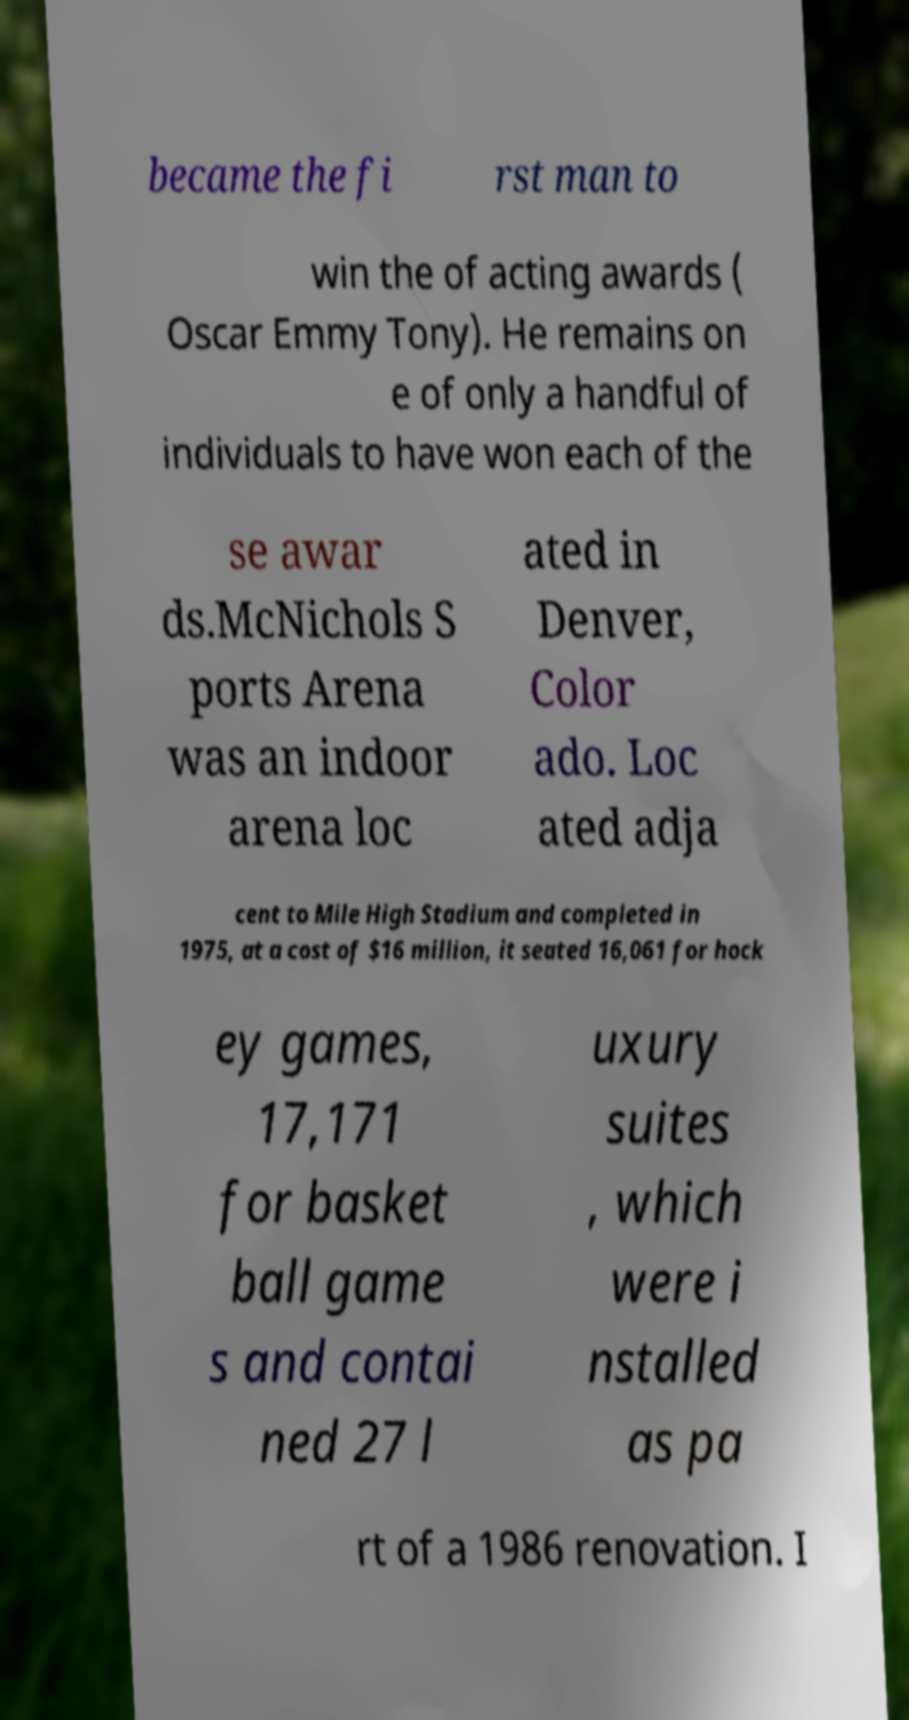Please identify and transcribe the text found in this image. became the fi rst man to win the of acting awards ( Oscar Emmy Tony). He remains on e of only a handful of individuals to have won each of the se awar ds.McNichols S ports Arena was an indoor arena loc ated in Denver, Color ado. Loc ated adja cent to Mile High Stadium and completed in 1975, at a cost of $16 million, it seated 16,061 for hock ey games, 17,171 for basket ball game s and contai ned 27 l uxury suites , which were i nstalled as pa rt of a 1986 renovation. I 